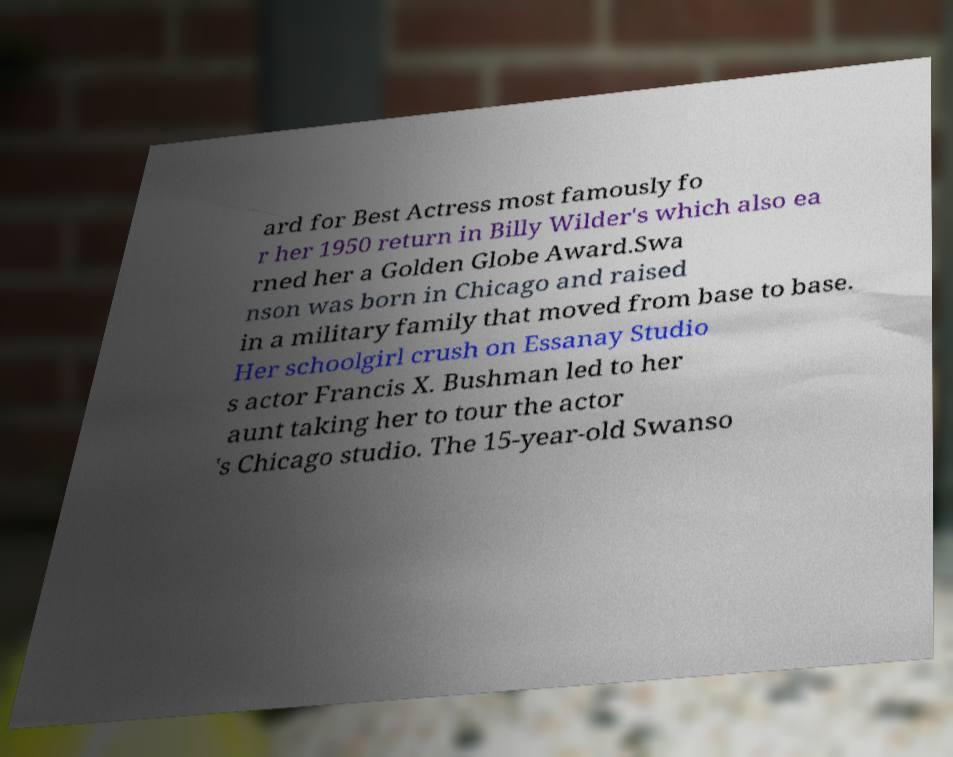For documentation purposes, I need the text within this image transcribed. Could you provide that? ard for Best Actress most famously fo r her 1950 return in Billy Wilder's which also ea rned her a Golden Globe Award.Swa nson was born in Chicago and raised in a military family that moved from base to base. Her schoolgirl crush on Essanay Studio s actor Francis X. Bushman led to her aunt taking her to tour the actor 's Chicago studio. The 15-year-old Swanso 